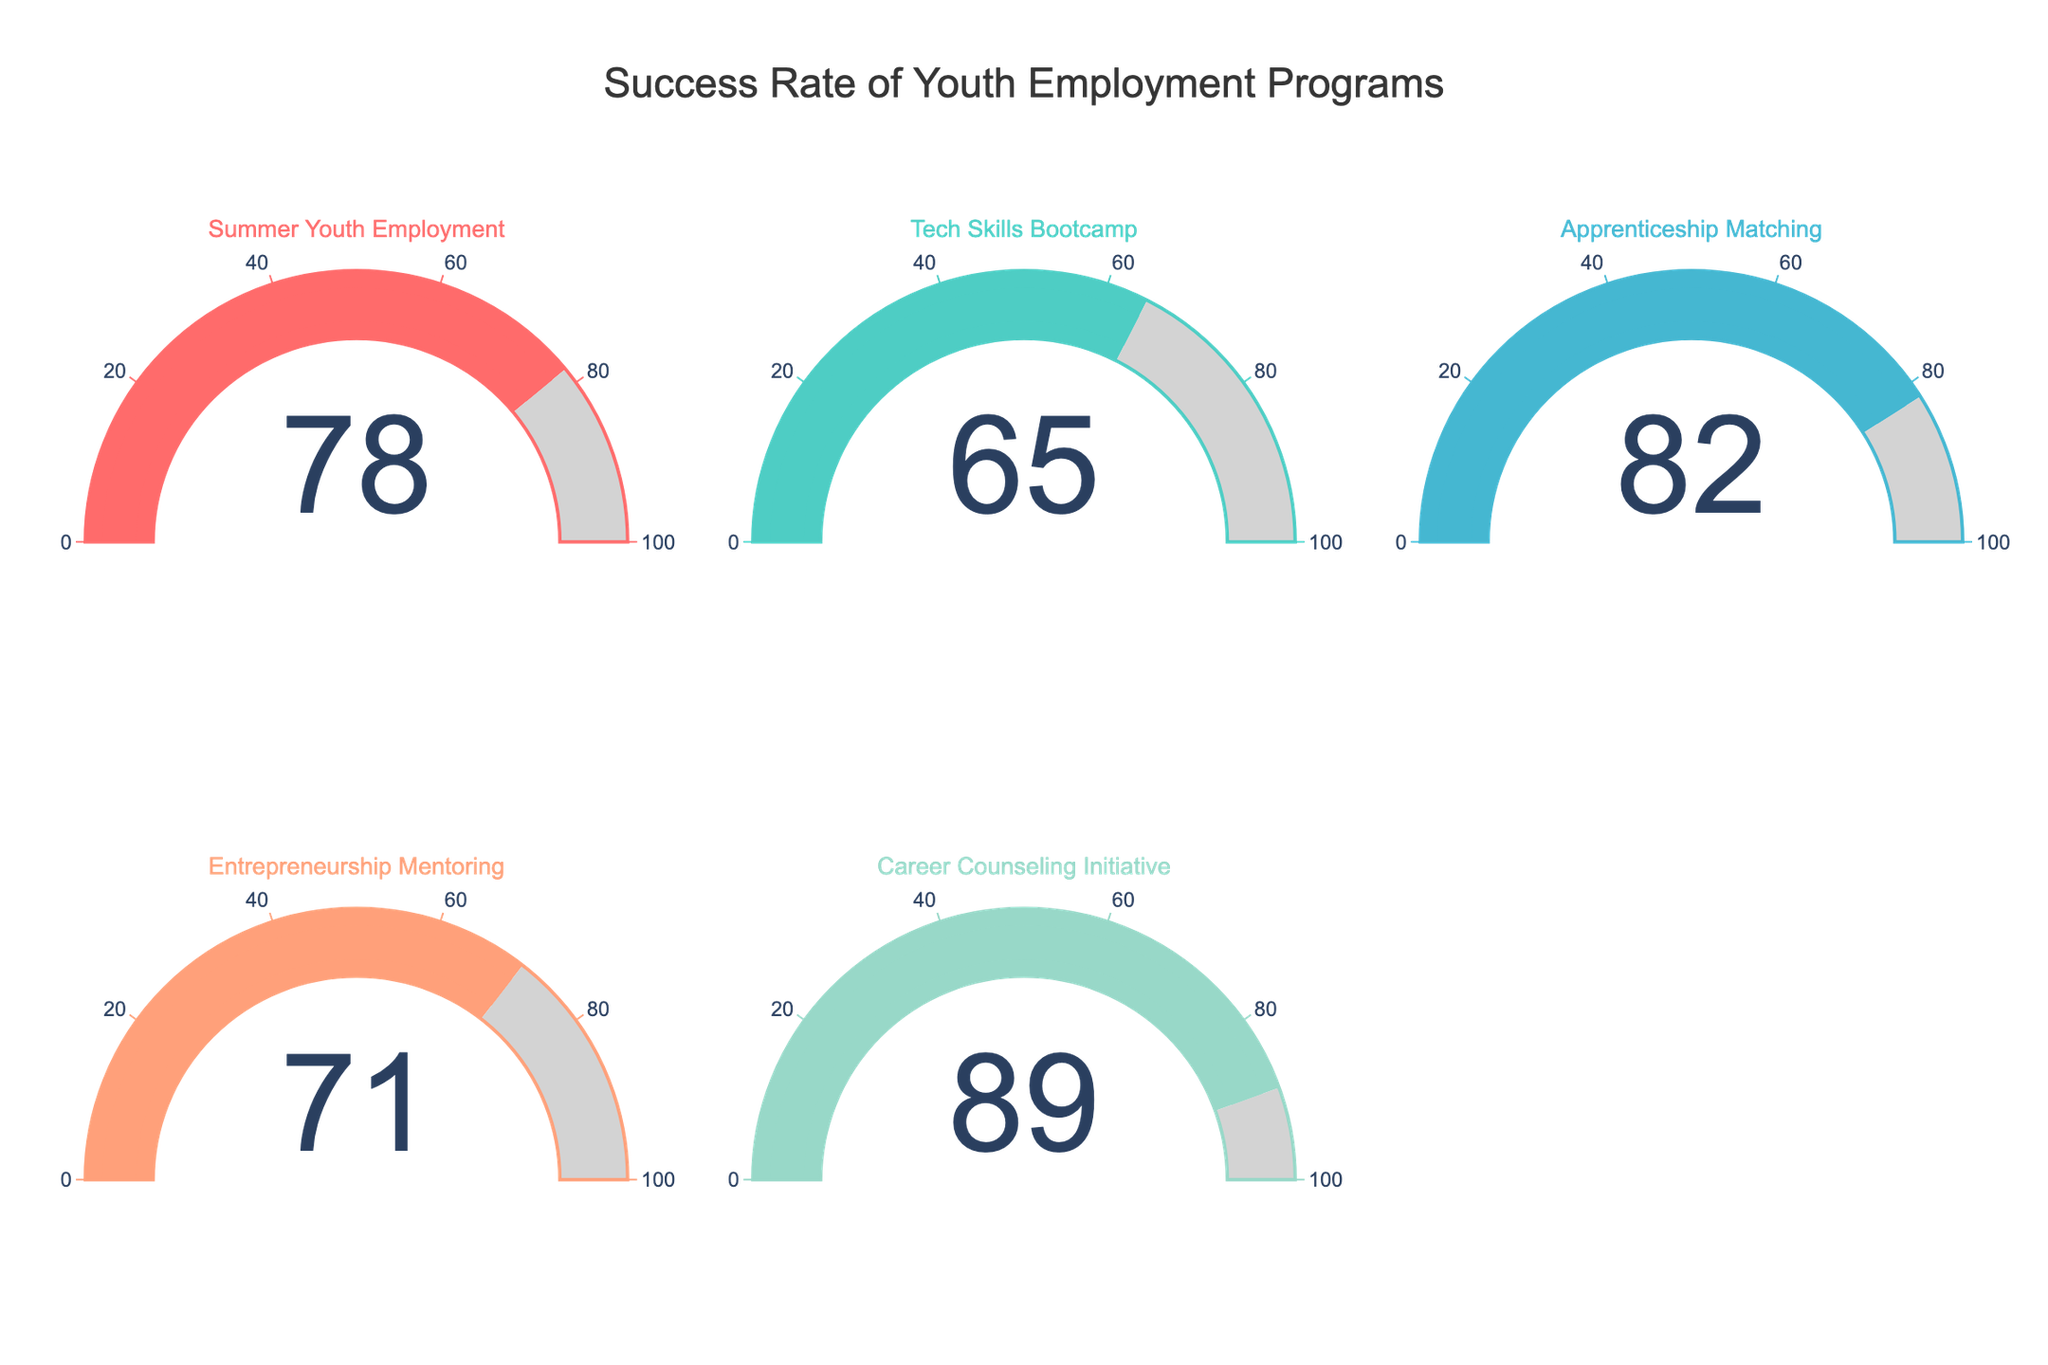what's the highest success rate among the youth employment programs? Look at each gauge to find the highest displayed value. The Career Counseling Initiative shows 89, which is the highest.
Answer: 89 Which program has the lowest success rate? Compare the success rate values displayed on each gauge. The Tech Skills Bootcamp has the lowest success rate with a value of 65.
Answer: Tech Skills Bootcamp What is the average success rate of all programs combined? Add all the success rates and divide by the number of programs. (78 + 65 + 82 + 71 + 89) / 5 = 385 / 5 = 77
Answer: 77 Which two programs have success rates closest to each other? Check the differences between each pair of success rates. Summer Youth Employment (78) and Entrepreneurship Mentoring (71) have a difference of 78 - 71 = 7, which is the smallest difference.
Answer: Summer Youth Employment and Entrepreneurship Mentoring How many programs have a success rate above 80%? Count the number of gauges with values above 80. Apprenticeship Matching (82) and Career Counseling Initiative (89) meet this criterion.
Answer: 2 What's the color associated with the Summer Youth Employment program? Identify the color of the bar, border, and gauge elements for the Summer Youth Employment program, which is displayed in red (#FF6B6B).
Answer: red If you were to improve each program’s success rate by 10%, what would be the new success rate for Career Counseling Initiative? Add 10% of the current success rate (89) to itself: 89 + 0.10 * 89 = 89 + 8.9 = 97.9
Answer: 97.9 Which program's success rate is closest to the average success rate of 77%? Calculate the absolute differences between each program's success rate and the average of 77%. The differences are: (78-77)=1, (65-77)=12, (82-77)=5, (71-77)=6, (89-77)=12. The Summer Youth Employment program (78) is 1% away from 77, the smallest difference.
Answer: Summer Youth Employment If Tech Skills Bootcamp improved its success rate by 20%, would it surpass Summer Youth Employment's success rate? Calculate the increased success rate of Tech Skills Bootcamp: 65 + 0.20 * 65 = 65 + 13 = 78. Compare it with Summer Youth Employment's rate of 78.
Answer: No 